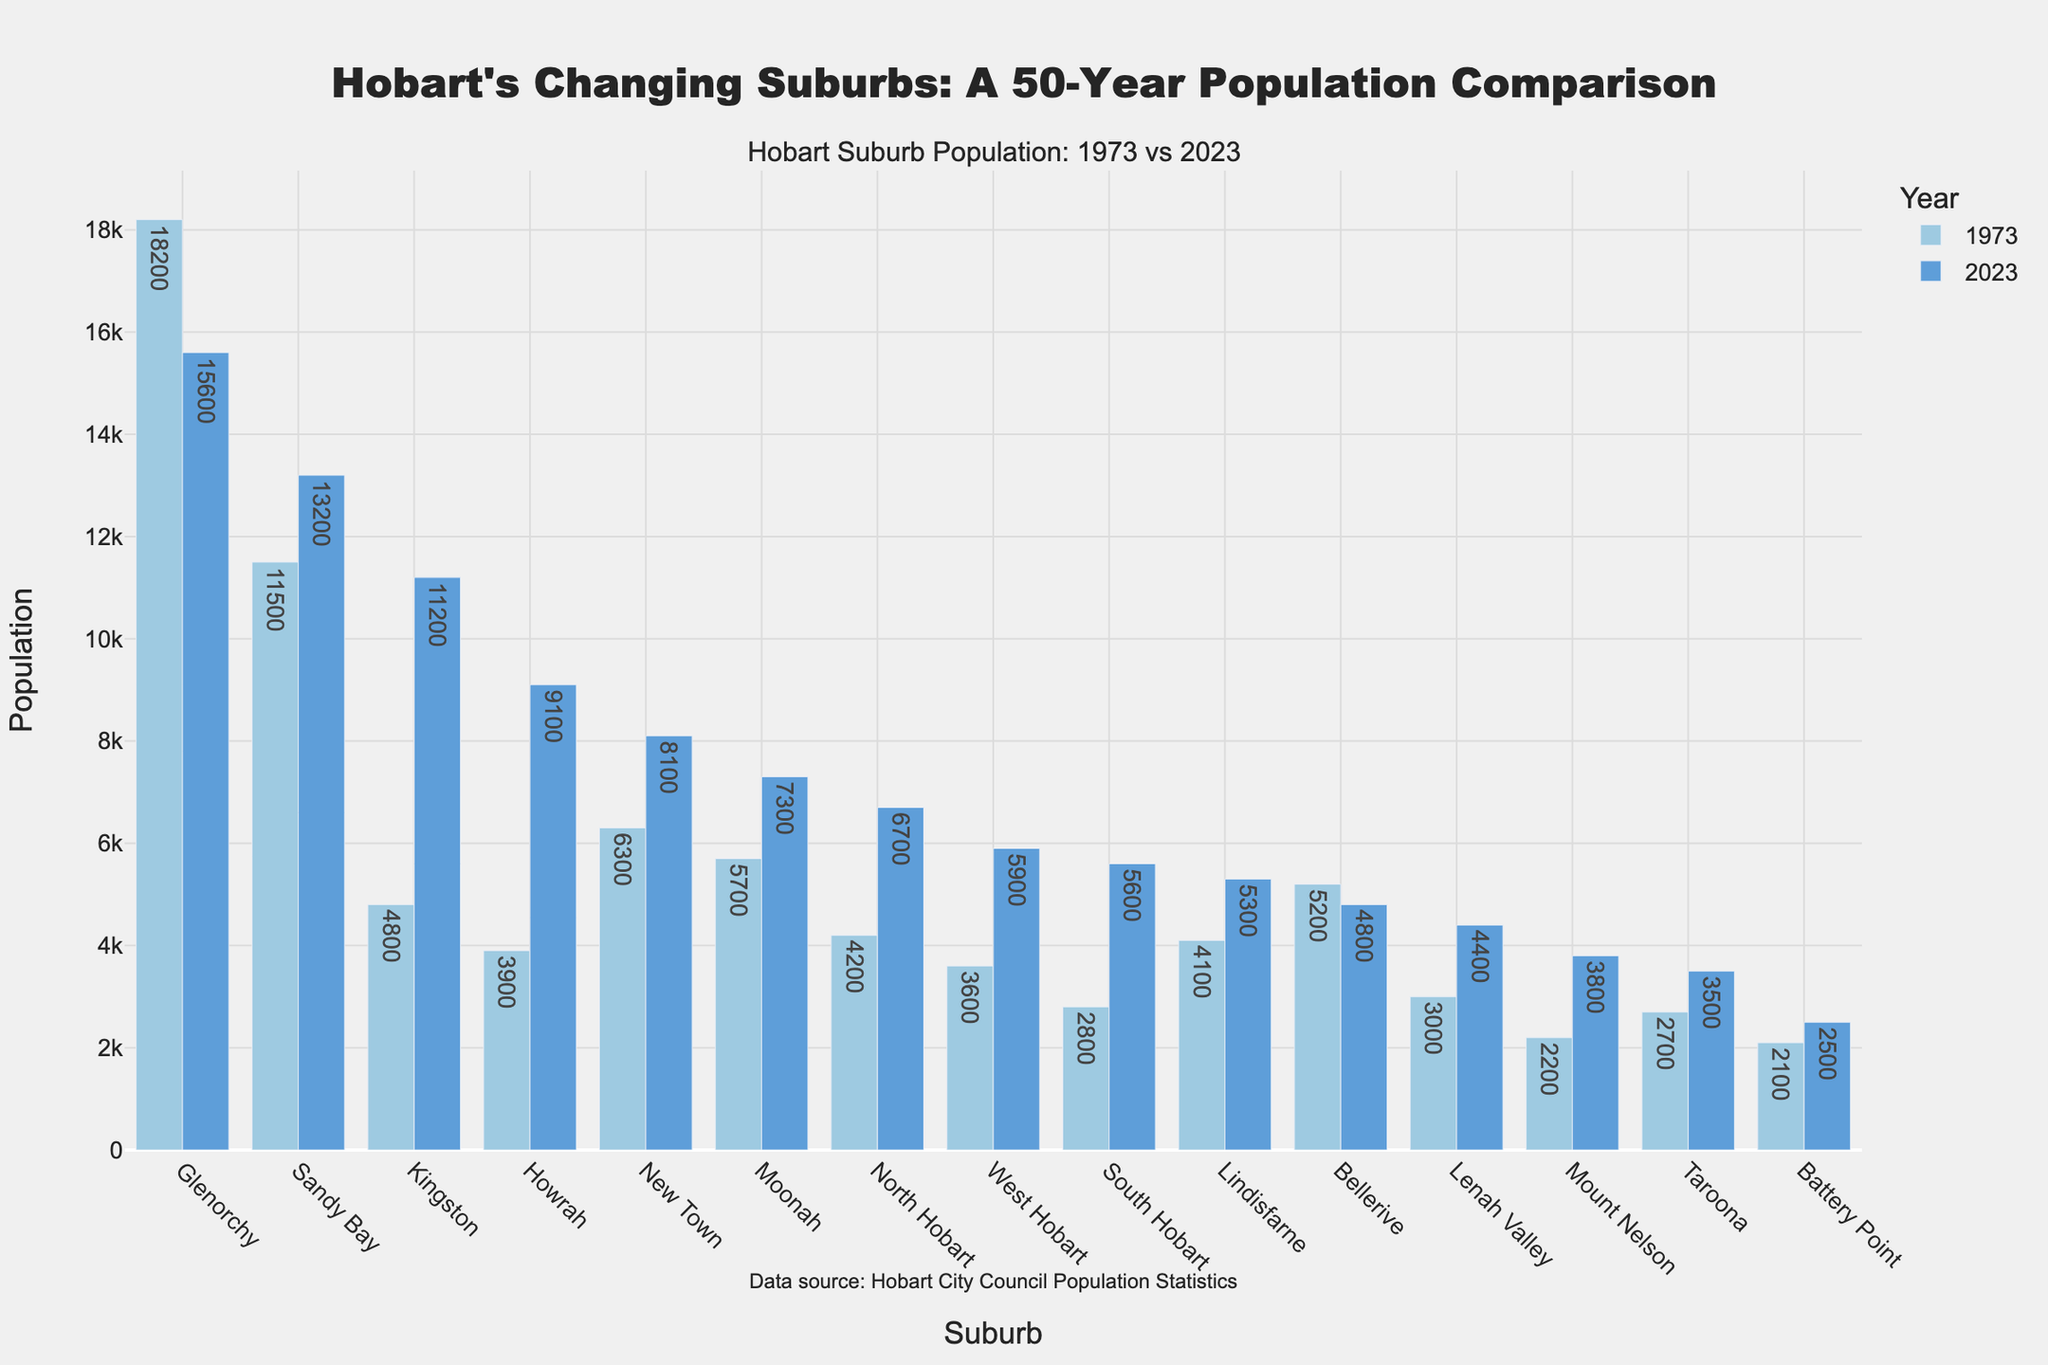Which suburb had the largest population in 2023? By comparing the heights of the bars for 2023, we can see that Sandy Bay has the tallest bar, indicating it had the largest population in 2023.
Answer: Sandy Bay How much did the population of Kingston increase from 1973 to 2023? Calculating the difference between the 2023 population and the 1973 population for Kingston: 11200 (2023) - 4800 (1973) = 6400
Answer: 6400 Which suburb saw a decrease in population over the 50 years? By analyzing the heights of the pairs of bars, we can see that Bellerive and Glenorchy had taller bars in 1973 compared to 2023.
Answer: Bellerive and Glenorchy What is the average population of Sandy Bay and New Town in 2023? Adding the populations of Sandy Bay and New Town in 2023 and dividing by 2: (13200 + 8100) / 2 = 10650
Answer: 10650 Which suburb had the smallest population in 1973? By comparing the heights of the bars for 1973, we can see that Battery Point has the shortest bar.
Answer: Battery Point Did Howrah or Mount Nelson experience a greater percentage increase in population? Calculate the percentage increase for each suburb:
For Howrah: ((9100 - 3900) / 3900) * 100 ≈ 133.33%
For Mount Nelson: ((3800 - 2200) / 2200) * 100 ≈ 72.73%
Howrah experienced a greater percentage increase.
Answer: Howrah Which suburbs had a population of more than 5000 in both 1973 and 2023? By comparing the heights of the pairs of bars, the suburbs with a population more than 5000 in both years are Sandy Bay, New Town, Moonah, and Glenorchy.
Answer: Sandy Bay, New Town, Moonah, Glenorchy What is the combined population of Battery Point, South Hobart, and Taroona in 2023? Sum the populations of Battery Point, South Hobart, and Taroona in 2023: 2500 + 5600 + 3500 = 11600
Answer: 11600 Which suburb had the second highest population in 2023? By comparing the heights of the bars for 2023, we find that Kingston has the second tallest bar.
Answer: Kingston 